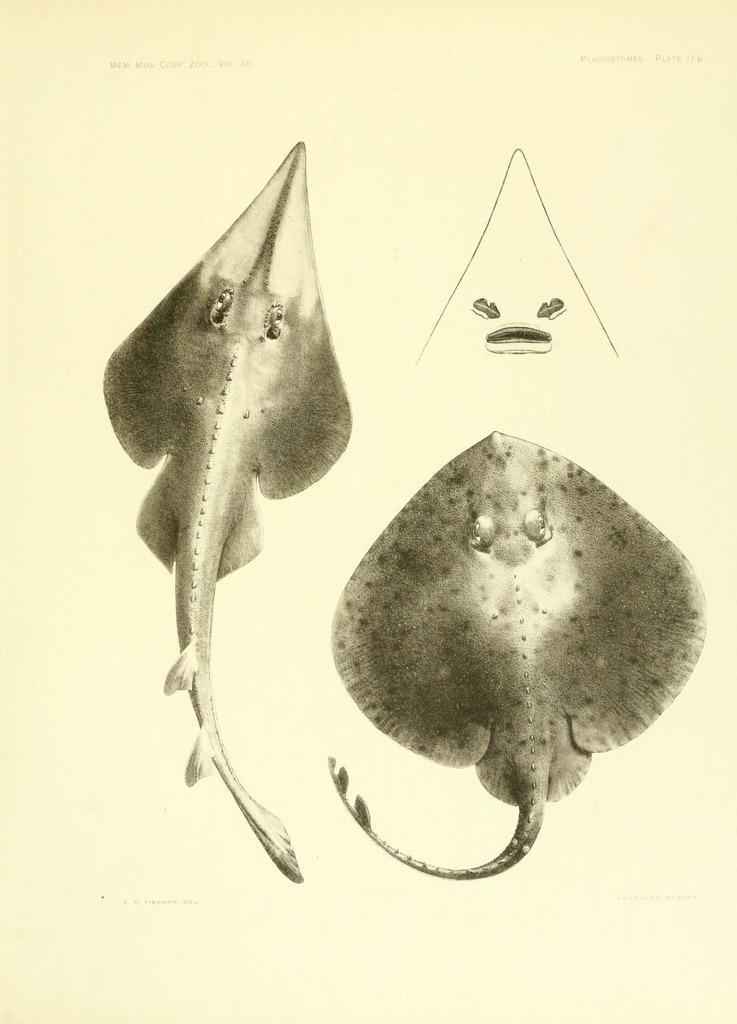What type of subjects are depicted in the sketches in the image? The sketches in the image contain water species. Can you describe the style or medium of the sketches? The provided facts do not mention the style or medium of the sketches. What is the primary focus of the image? The primary focus of the image is the sketches of water species. What type of instrument is being played in the image? There is no instrument present in the image; it contains sketches of water species. How many yards of fabric are visible in the image? There is no fabric present in the image; it contains sketches of water species. 